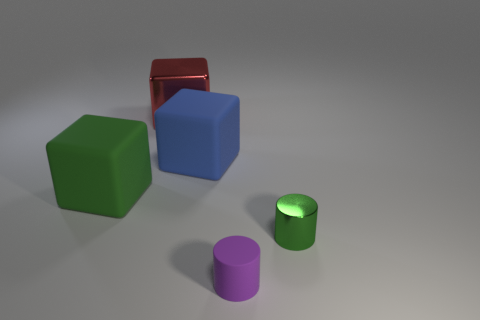Subtract all red metal cubes. How many cubes are left? 2 Add 5 small green objects. How many objects exist? 10 Subtract all purple cylinders. How many cylinders are left? 1 Subtract 2 blocks. How many blocks are left? 1 Add 5 green shiny things. How many green shiny things are left? 6 Add 1 big red metallic cubes. How many big red metallic cubes exist? 2 Subtract 0 green spheres. How many objects are left? 5 Subtract all cylinders. How many objects are left? 3 Subtract all brown cubes. Subtract all purple spheres. How many cubes are left? 3 Subtract all red spheres. How many purple cylinders are left? 1 